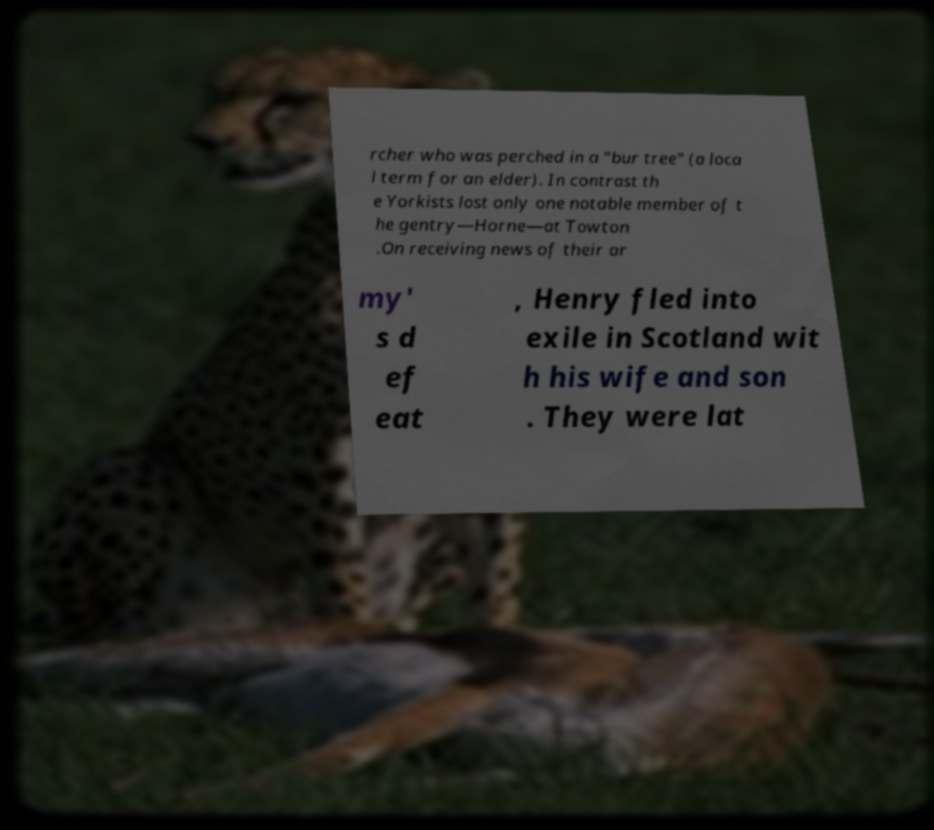What messages or text are displayed in this image? I need them in a readable, typed format. rcher who was perched in a "bur tree" (a loca l term for an elder). In contrast th e Yorkists lost only one notable member of t he gentry—Horne—at Towton .On receiving news of their ar my' s d ef eat , Henry fled into exile in Scotland wit h his wife and son . They were lat 